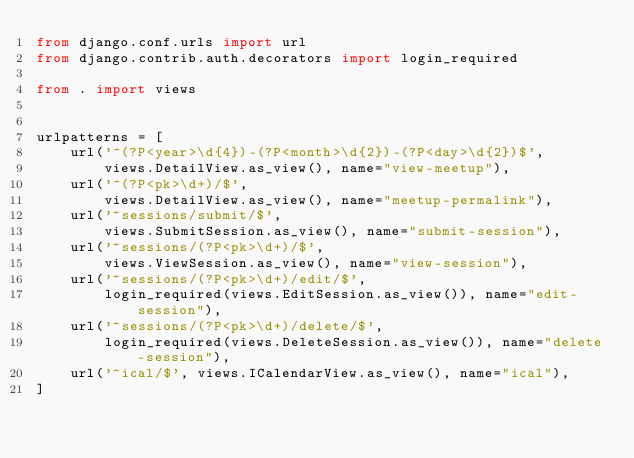<code> <loc_0><loc_0><loc_500><loc_500><_Python_>from django.conf.urls import url
from django.contrib.auth.decorators import login_required

from . import views


urlpatterns = [
    url('^(?P<year>\d{4})-(?P<month>\d{2})-(?P<day>\d{2})$',
        views.DetailView.as_view(), name="view-meetup"),
    url('^(?P<pk>\d+)/$',
        views.DetailView.as_view(), name="meetup-permalink"),
    url('^sessions/submit/$',
        views.SubmitSession.as_view(), name="submit-session"),
    url('^sessions/(?P<pk>\d+)/$',
        views.ViewSession.as_view(), name="view-session"),
    url('^sessions/(?P<pk>\d+)/edit/$',
        login_required(views.EditSession.as_view()), name="edit-session"),
    url('^sessions/(?P<pk>\d+)/delete/$',
        login_required(views.DeleteSession.as_view()), name="delete-session"),
    url('^ical/$', views.ICalendarView.as_view(), name="ical"),
]
</code> 